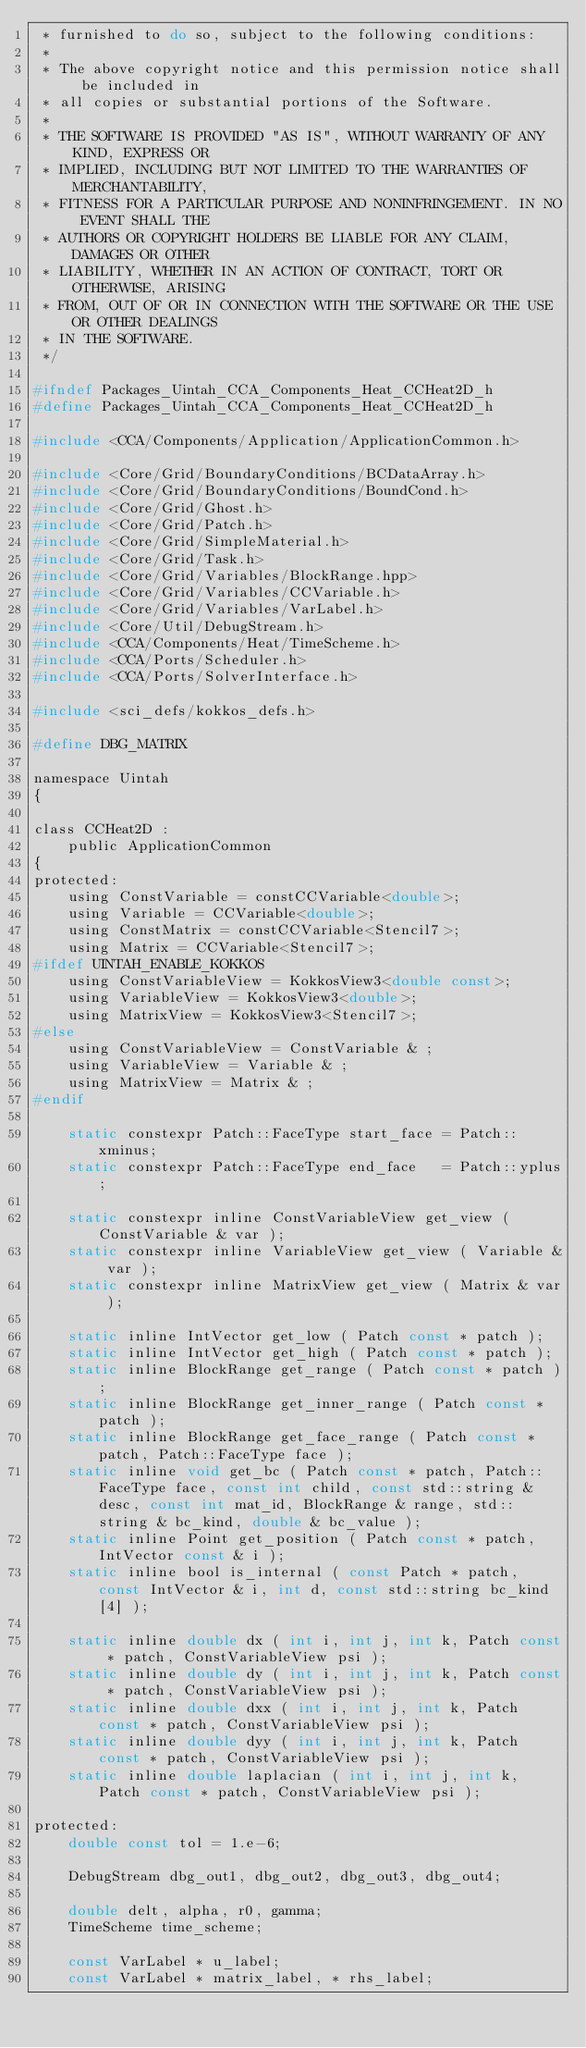Convert code to text. <code><loc_0><loc_0><loc_500><loc_500><_C_> * furnished to do so, subject to the following conditions:
 *
 * The above copyright notice and this permission notice shall be included in
 * all copies or substantial portions of the Software.
 *
 * THE SOFTWARE IS PROVIDED "AS IS", WITHOUT WARRANTY OF ANY KIND, EXPRESS OR
 * IMPLIED, INCLUDING BUT NOT LIMITED TO THE WARRANTIES OF MERCHANTABILITY,
 * FITNESS FOR A PARTICULAR PURPOSE AND NONINFRINGEMENT. IN NO EVENT SHALL THE
 * AUTHORS OR COPYRIGHT HOLDERS BE LIABLE FOR ANY CLAIM, DAMAGES OR OTHER
 * LIABILITY, WHETHER IN AN ACTION OF CONTRACT, TORT OR OTHERWISE, ARISING
 * FROM, OUT OF OR IN CONNECTION WITH THE SOFTWARE OR THE USE OR OTHER DEALINGS
 * IN THE SOFTWARE.
 */

#ifndef Packages_Uintah_CCA_Components_Heat_CCHeat2D_h
#define Packages_Uintah_CCA_Components_Heat_CCHeat2D_h

#include <CCA/Components/Application/ApplicationCommon.h>

#include <Core/Grid/BoundaryConditions/BCDataArray.h>
#include <Core/Grid/BoundaryConditions/BoundCond.h>
#include <Core/Grid/Ghost.h>
#include <Core/Grid/Patch.h>
#include <Core/Grid/SimpleMaterial.h>
#include <Core/Grid/Task.h>
#include <Core/Grid/Variables/BlockRange.hpp>
#include <Core/Grid/Variables/CCVariable.h>
#include <Core/Grid/Variables/VarLabel.h>
#include <Core/Util/DebugStream.h>
#include <CCA/Components/Heat/TimeScheme.h>
#include <CCA/Ports/Scheduler.h>
#include <CCA/Ports/SolverInterface.h>

#include <sci_defs/kokkos_defs.h>

#define DBG_MATRIX

namespace Uintah
{

class CCHeat2D :
    public ApplicationCommon
{
protected:
    using ConstVariable = constCCVariable<double>;
    using Variable = CCVariable<double>;
    using ConstMatrix = constCCVariable<Stencil7>;
    using Matrix = CCVariable<Stencil7>;
#ifdef UINTAH_ENABLE_KOKKOS
    using ConstVariableView = KokkosView3<double const>;
    using VariableView = KokkosView3<double>;
    using MatrixView = KokkosView3<Stencil7>;
#else
    using ConstVariableView = ConstVariable & ;
    using VariableView = Variable & ;
    using MatrixView = Matrix & ;
#endif

    static constexpr Patch::FaceType start_face = Patch::xminus;
    static constexpr Patch::FaceType end_face   = Patch::yplus;

    static constexpr inline ConstVariableView get_view ( ConstVariable & var );
    static constexpr inline VariableView get_view ( Variable & var );
    static constexpr inline MatrixView get_view ( Matrix & var );

    static inline IntVector get_low ( Patch const * patch );
    static inline IntVector get_high ( Patch const * patch );
    static inline BlockRange get_range ( Patch const * patch );
    static inline BlockRange get_inner_range ( Patch const * patch );
    static inline BlockRange get_face_range ( Patch const * patch, Patch::FaceType face );
    static inline void get_bc ( Patch const * patch, Patch::FaceType face, const int child, const std::string & desc, const int mat_id, BlockRange & range, std::string & bc_kind, double & bc_value );
    static inline Point get_position ( Patch const * patch, IntVector const & i );
    static inline bool is_internal ( const Patch * patch, const IntVector & i, int d, const std::string bc_kind[4] );

    static inline double dx ( int i, int j, int k, Patch const * patch, ConstVariableView psi );
    static inline double dy ( int i, int j, int k, Patch const * patch, ConstVariableView psi );
    static inline double dxx ( int i, int j, int k, Patch const * patch, ConstVariableView psi );
    static inline double dyy ( int i, int j, int k, Patch const * patch, ConstVariableView psi );
    static inline double laplacian ( int i, int j, int k, Patch const * patch, ConstVariableView psi );

protected:
    double const tol = 1.e-6;

    DebugStream dbg_out1, dbg_out2, dbg_out3, dbg_out4;

    double delt, alpha, r0, gamma;
    TimeScheme time_scheme;

    const VarLabel * u_label;
    const VarLabel * matrix_label, * rhs_label;</code> 